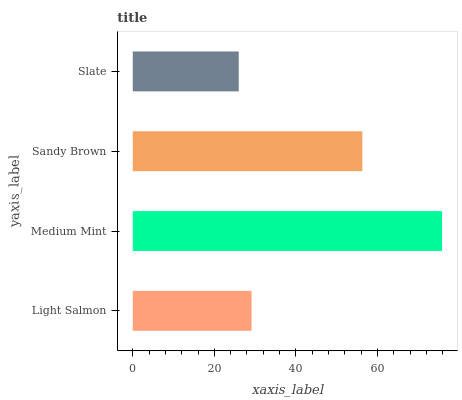Is Slate the minimum?
Answer yes or no. Yes. Is Medium Mint the maximum?
Answer yes or no. Yes. Is Sandy Brown the minimum?
Answer yes or no. No. Is Sandy Brown the maximum?
Answer yes or no. No. Is Medium Mint greater than Sandy Brown?
Answer yes or no. Yes. Is Sandy Brown less than Medium Mint?
Answer yes or no. Yes. Is Sandy Brown greater than Medium Mint?
Answer yes or no. No. Is Medium Mint less than Sandy Brown?
Answer yes or no. No. Is Sandy Brown the high median?
Answer yes or no. Yes. Is Light Salmon the low median?
Answer yes or no. Yes. Is Medium Mint the high median?
Answer yes or no. No. Is Sandy Brown the low median?
Answer yes or no. No. 